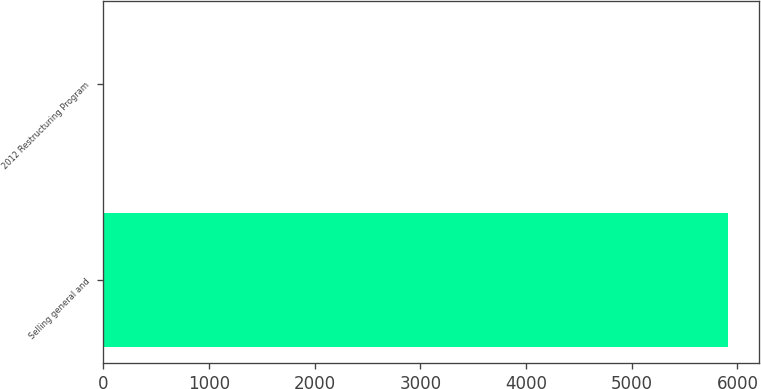Convert chart to OTSL. <chart><loc_0><loc_0><loc_500><loc_500><bar_chart><fcel>Selling general and<fcel>2012 Restructuring Program<nl><fcel>5910<fcel>6<nl></chart> 